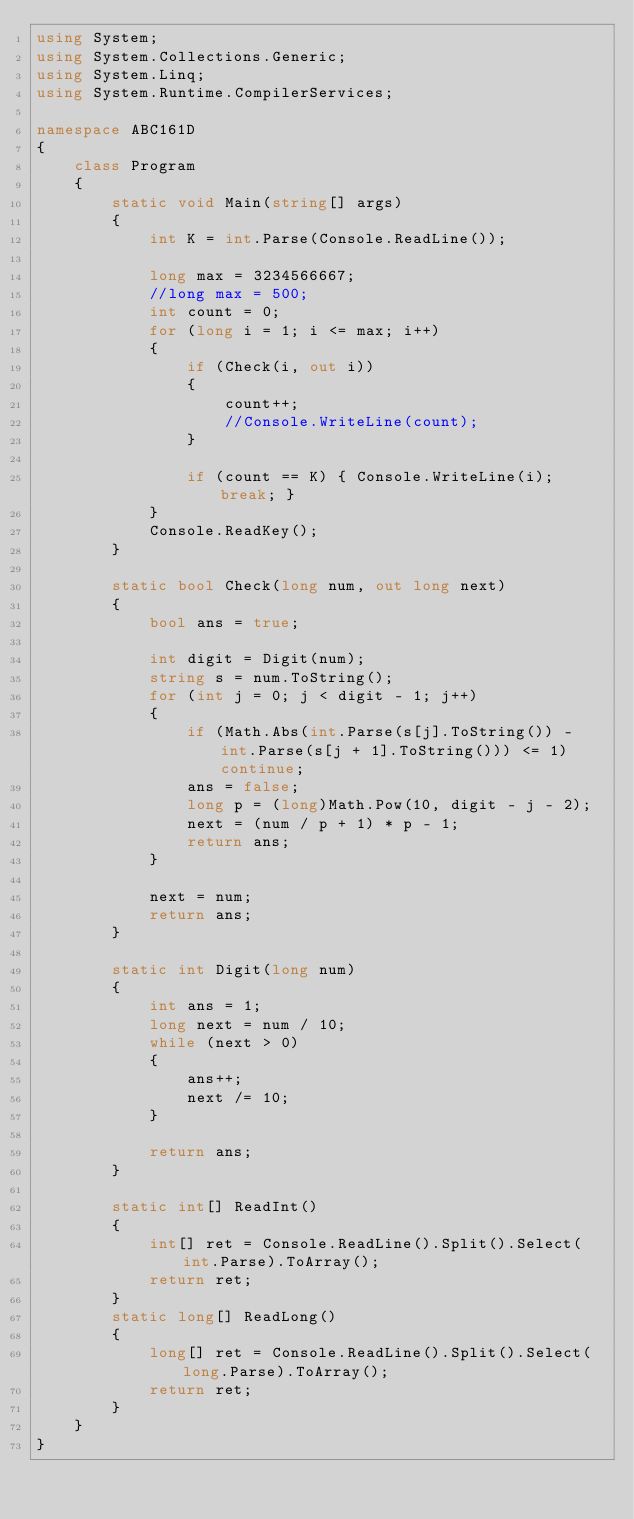Convert code to text. <code><loc_0><loc_0><loc_500><loc_500><_C#_>using System;
using System.Collections.Generic;
using System.Linq;
using System.Runtime.CompilerServices;

namespace ABC161D
{
    class Program
    {
        static void Main(string[] args)
        {
            int K = int.Parse(Console.ReadLine());

            long max = 3234566667;
            //long max = 500;
            int count = 0;
            for (long i = 1; i <= max; i++)
            {
                if (Check(i, out i))
                {
                    count++;
                    //Console.WriteLine(count);
                }

                if (count == K) { Console.WriteLine(i); break; }
            }
            Console.ReadKey();
        }

        static bool Check(long num, out long next)
        {
            bool ans = true;

            int digit = Digit(num);
            string s = num.ToString();
            for (int j = 0; j < digit - 1; j++)
            {
                if (Math.Abs(int.Parse(s[j].ToString()) - int.Parse(s[j + 1].ToString())) <= 1) continue;
                ans = false;
                long p = (long)Math.Pow(10, digit - j - 2);
                next = (num / p + 1) * p - 1;
                return ans;
            }

            next = num;
            return ans;
        }

        static int Digit(long num)
        {
            int ans = 1;
            long next = num / 10;
            while (next > 0)
            {
                ans++;
                next /= 10;
            }

            return ans;
        }

        static int[] ReadInt()
        {
            int[] ret = Console.ReadLine().Split().Select(int.Parse).ToArray();
            return ret;
        }
        static long[] ReadLong()
        {
            long[] ret = Console.ReadLine().Split().Select(long.Parse).ToArray();
            return ret;
        }
    }
}
</code> 